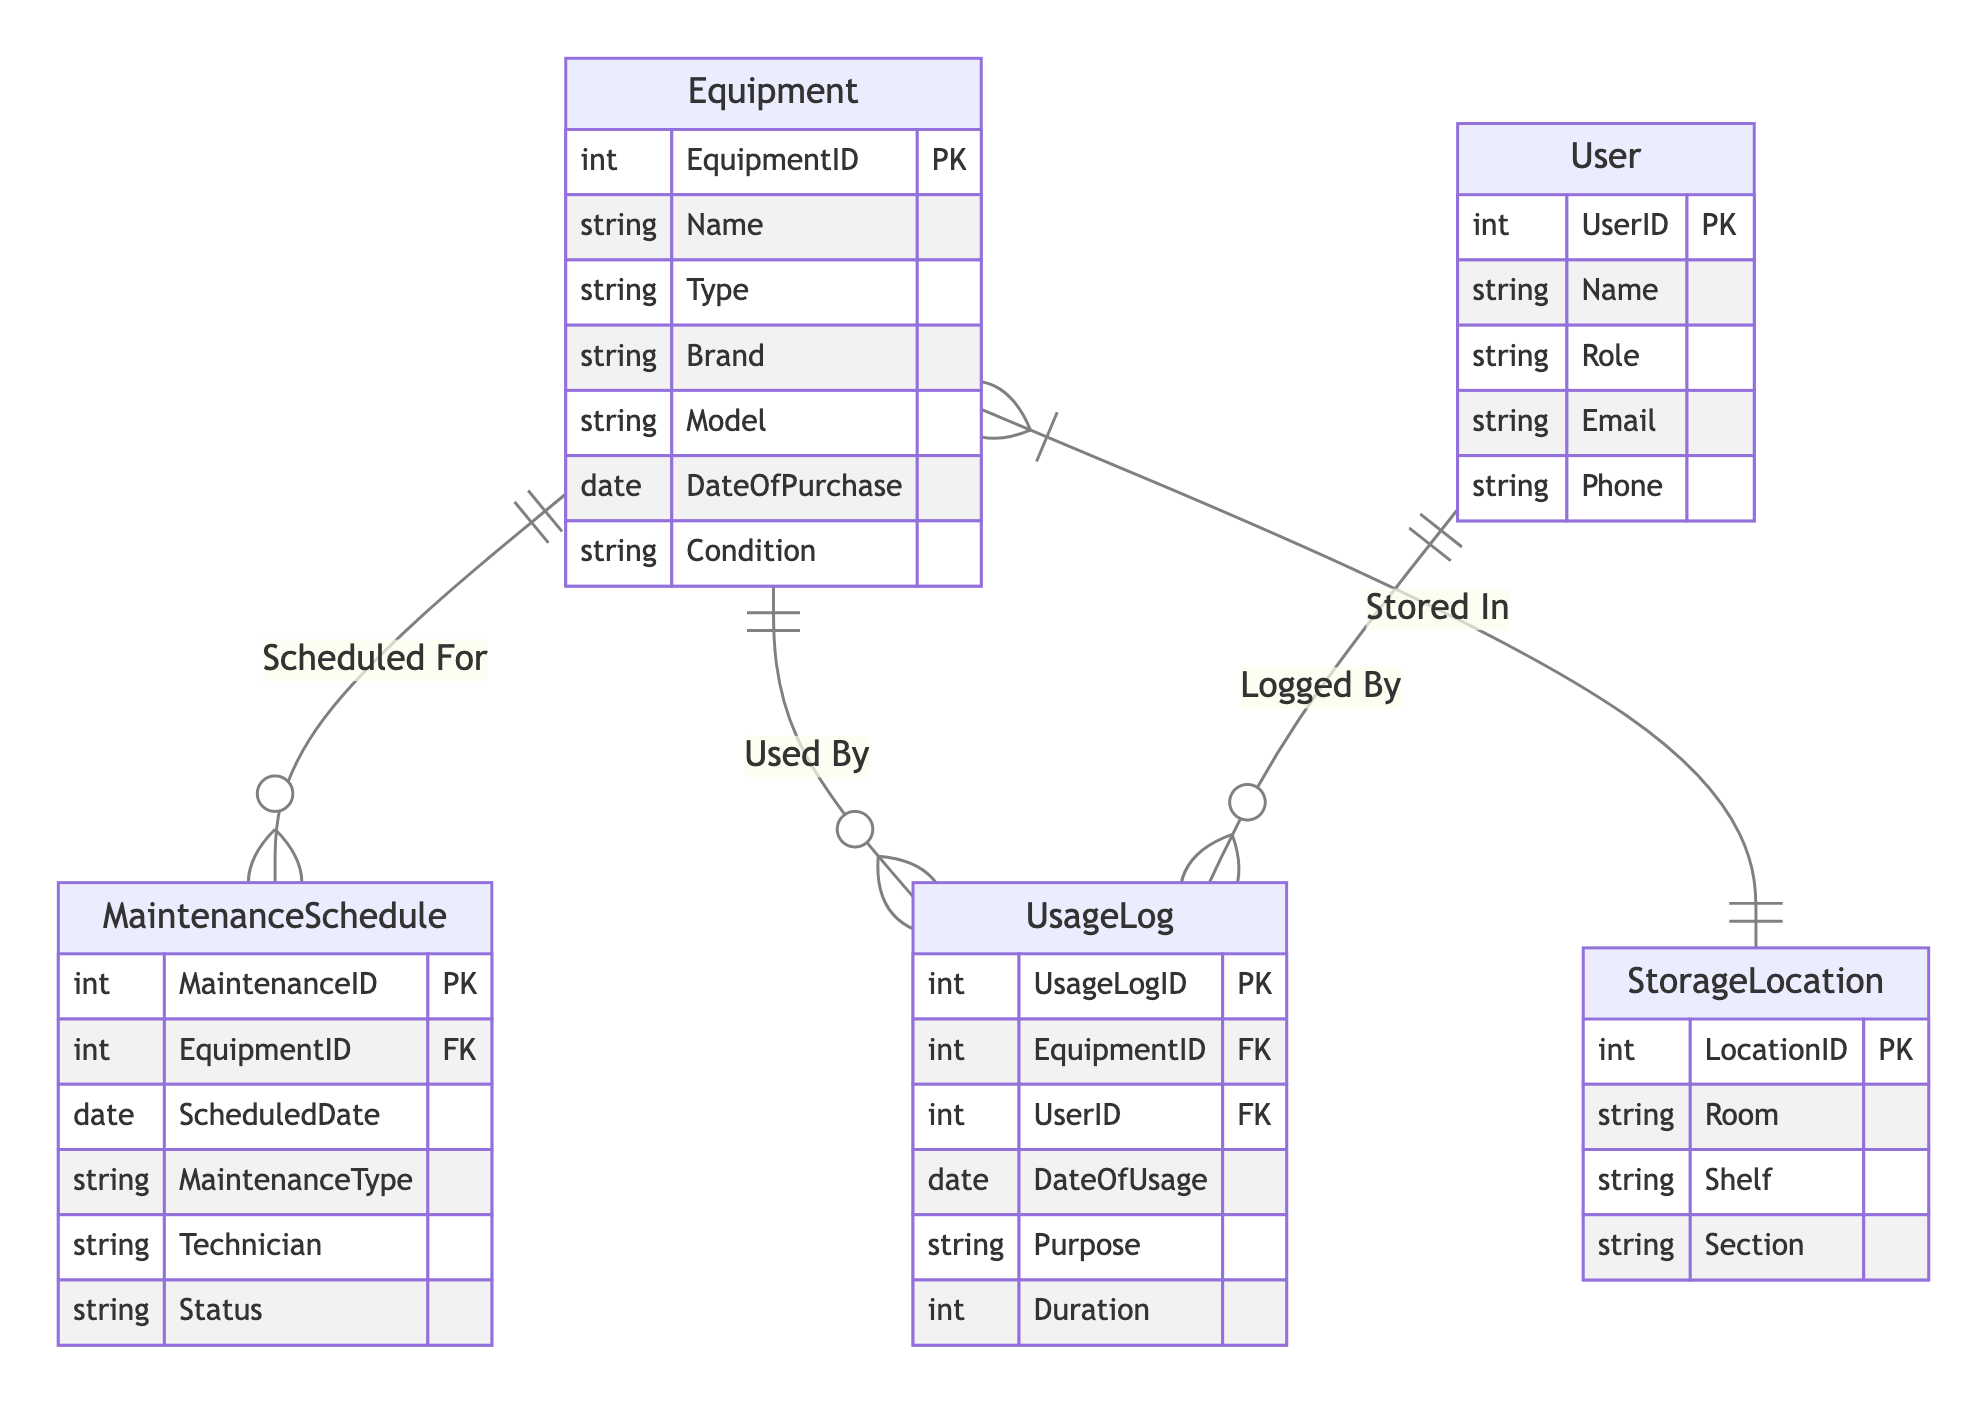What is the primary key of the Equipment entity? The primary key of the Equipment entity is EquipmentID, which uniquely identifies each piece of equipment in the system.
Answer: EquipmentID How many entities are present in the diagram? The diagram contains five distinct entities: Equipment, StorageLocation, MaintenanceSchedule, UsageLog, and User.
Answer: Five What type of relationship exists between Equipment and StorageLocation? The relationship between Equipment and StorageLocation is Many-to-One, meaning that multiple pieces of equipment can be stored in one storage location, but each equipment is stored in only one location.
Answer: Many-to-One Which entity has a foreign key related to MaintenanceSchedule? The MaintenanceSchedule entity contains a foreign key named EquipmentID, linking it back to the Equipment entity to indicate which piece of equipment is scheduled for maintenance.
Answer: Equipment How many attributes does the UsageLog entity have? The UsageLog entity has five attributes: UsageLogID, EquipmentID, UserID, DateOfUsage, Purpose, and Duration.
Answer: Five Which entity is related to the User entity through a foreign key? The UsageLog entity is related to the User entity through UserID, indicating who logged the usage of the equipment.
Answer: UsageLog What does the term "Logged By" represent in the diagram? "Logged By" represents the One-to-Many relationship between User and UsageLog, indicating that one user can log multiple usage entries for different pieces of equipment.
Answer: UsageLog Are there any dependencies indicated in the relationships of the diagram? Yes, the relationships illustrate that for each Equipment entry, there could be multiple MaintenanceSchedule and UsageLog entries, indicating dependencies for maintenance and usage tracking.
Answer: Yes What is the purpose of the foreign key in the UsageLog? The foreign key in the UsageLog, which is EquipmentID, connects the usage log to the specific equipment being used, thus providing context for each log entry.
Answer: Connects to Equipment 